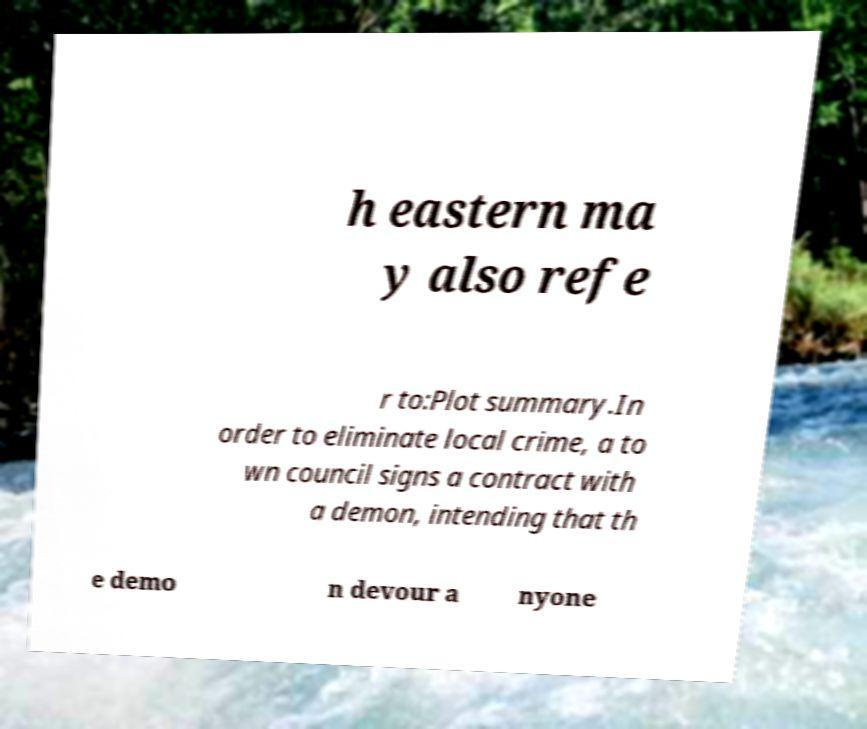Could you assist in decoding the text presented in this image and type it out clearly? h eastern ma y also refe r to:Plot summary.In order to eliminate local crime, a to wn council signs a contract with a demon, intending that th e demo n devour a nyone 